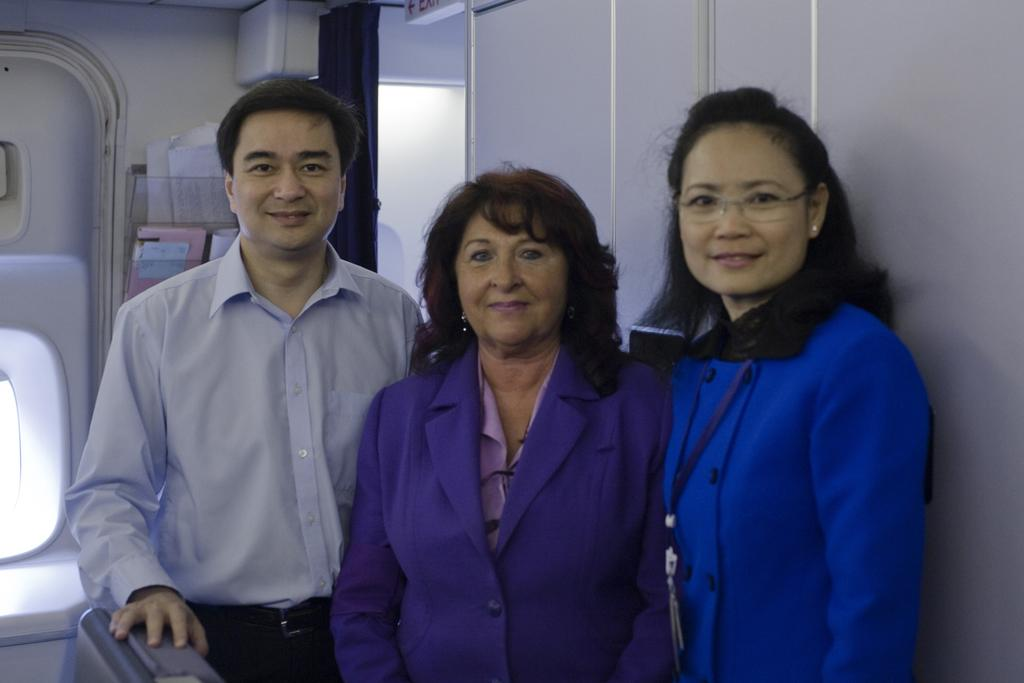What are the people in the image doing? The people in the image are standing inside a flight. What can be seen at the back side of the image? There is a window at the back side of the image. What is located beside the window? Papers and a speaker are present beside the window. What type of window treatment is visible in the image? Blue curtains are visible in the image. What type of garden can be seen through the window in the image? There is no garden visible through the window in the image; it is a flight, and the window likely shows the view outside the aircraft. 